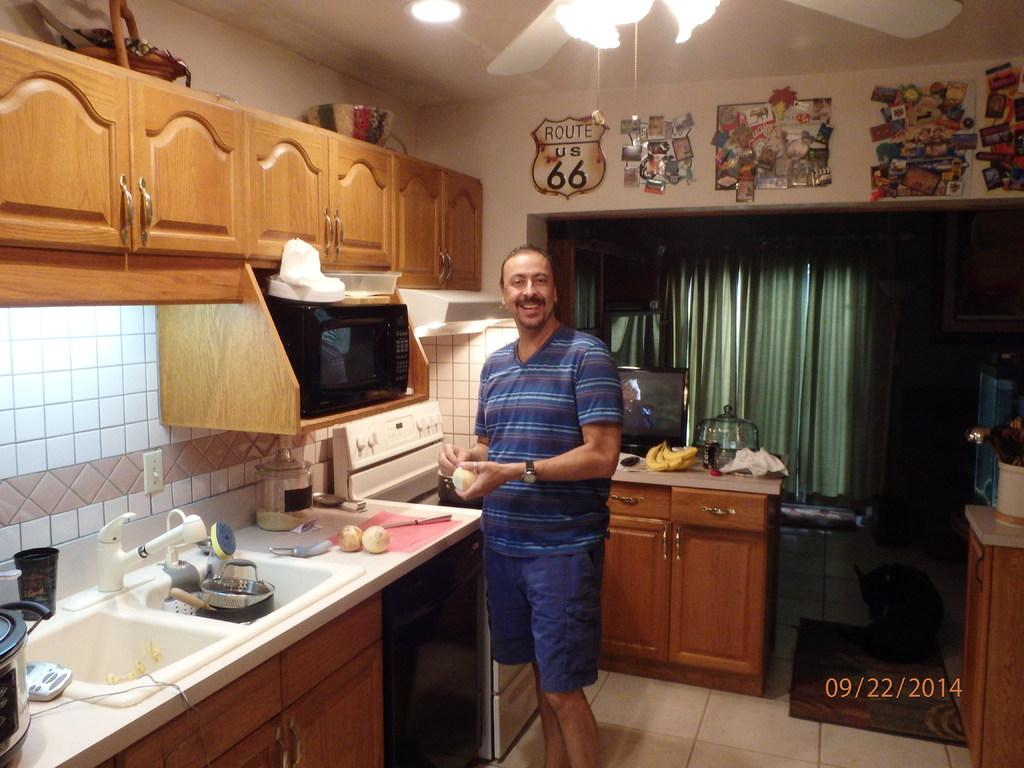<image>
Summarize the visual content of the image. a man stands in a kitchen under a Route 66 sign 